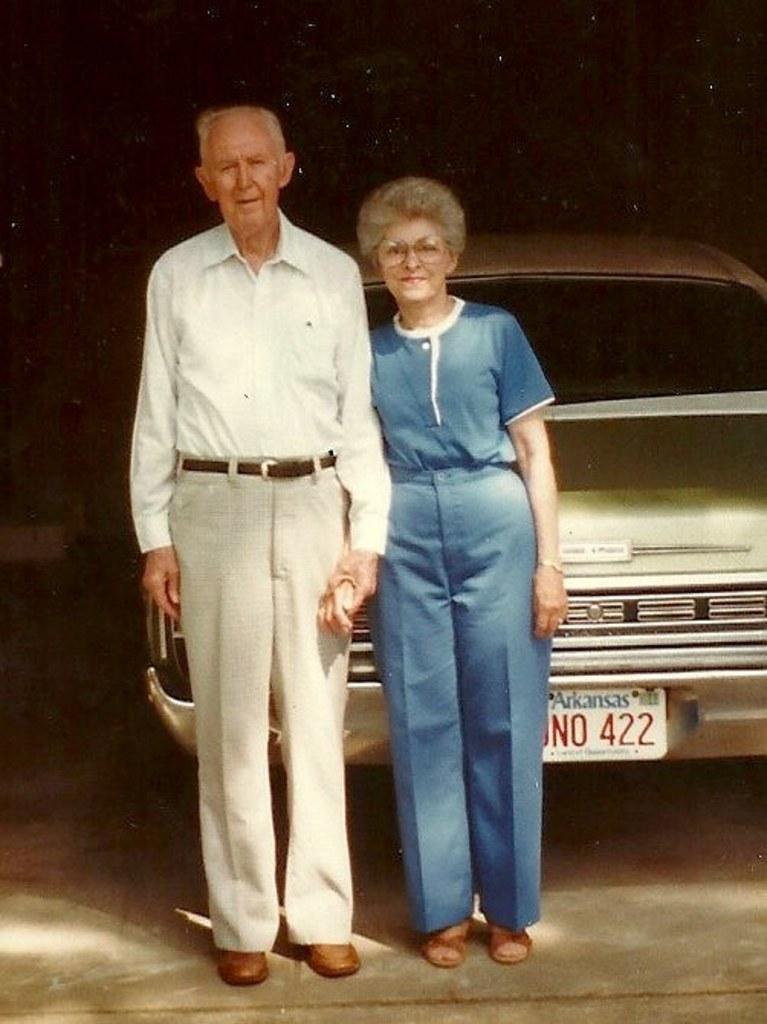Please provide a concise description of this image. In this picture we can see two people and a vehicle on the ground and in the background we can see it is dark. 